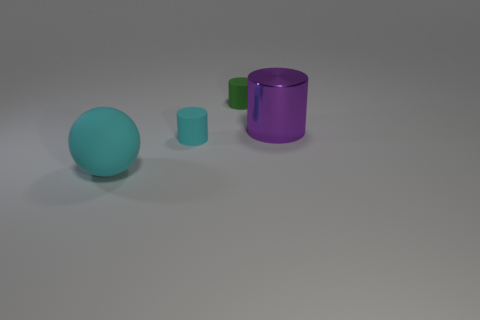Subtract all cyan matte cylinders. How many cylinders are left? 2 Add 4 red blocks. How many objects exist? 8 Subtract 2 cylinders. How many cylinders are left? 1 Subtract all purple cylinders. How many cylinders are left? 2 Add 2 rubber things. How many rubber things are left? 5 Add 2 large objects. How many large objects exist? 4 Subtract 0 brown cylinders. How many objects are left? 4 Subtract all cylinders. How many objects are left? 1 Subtract all yellow cylinders. Subtract all purple spheres. How many cylinders are left? 3 Subtract all green cubes. How many purple cylinders are left? 1 